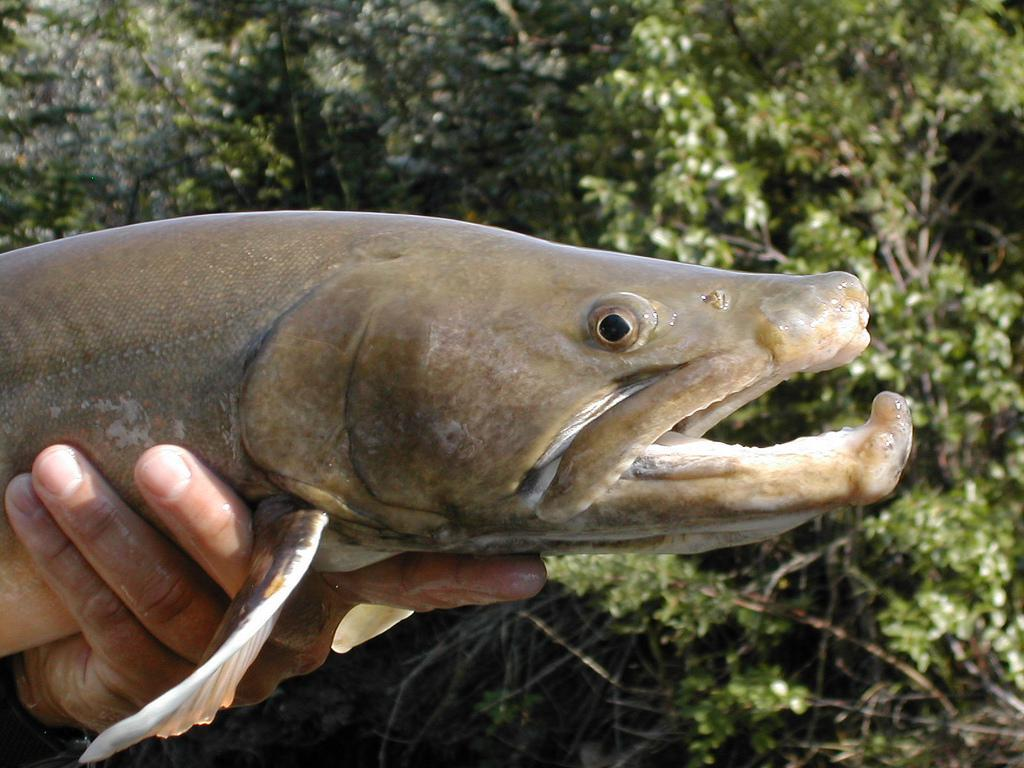What is the person holding in the image? There is a person's hand holding a fish in the image. What can be seen in the background of the image? There are trees visible in the background of the image. What type of leather is being used to play basketball in the image? There is no leather or basketball present in the image; it features a person's hand holding a fish and trees in the background. 